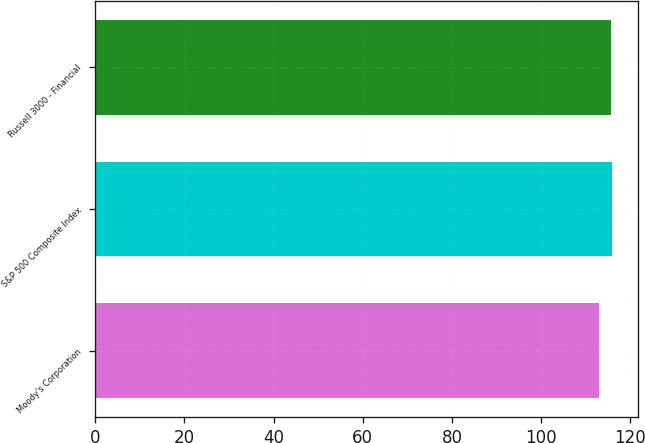Convert chart. <chart><loc_0><loc_0><loc_500><loc_500><bar_chart><fcel>Moody's Corporation<fcel>S&P 500 Composite Index<fcel>Russell 3000 - Financial<nl><fcel>112.94<fcel>115.83<fcel>115.55<nl></chart> 